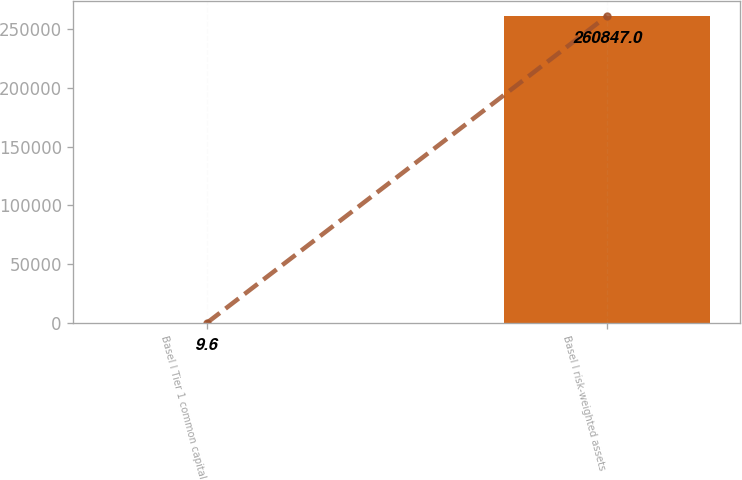<chart> <loc_0><loc_0><loc_500><loc_500><bar_chart><fcel>Basel I Tier 1 common capital<fcel>Basel I risk-weighted assets<nl><fcel>9.6<fcel>260847<nl></chart> 